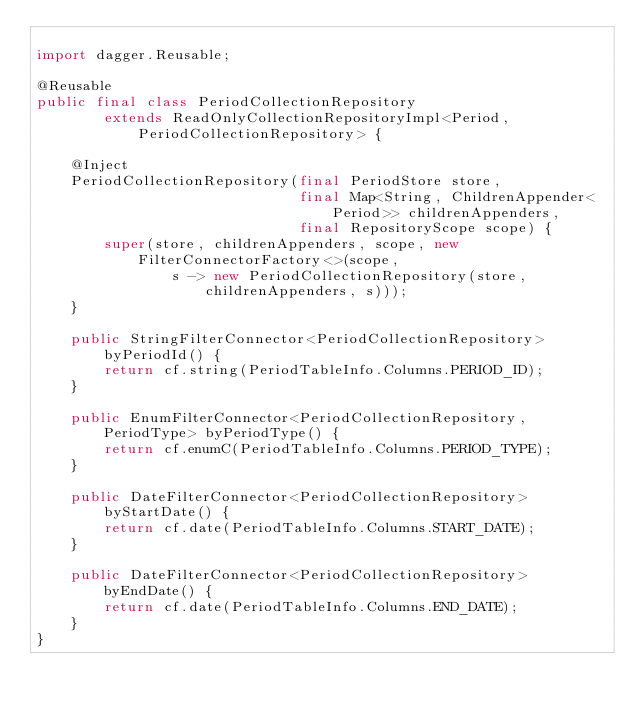Convert code to text. <code><loc_0><loc_0><loc_500><loc_500><_Java_>
import dagger.Reusable;

@Reusable
public final class PeriodCollectionRepository
        extends ReadOnlyCollectionRepositoryImpl<Period, PeriodCollectionRepository> {

    @Inject
    PeriodCollectionRepository(final PeriodStore store,
                               final Map<String, ChildrenAppender<Period>> childrenAppenders,
                               final RepositoryScope scope) {
        super(store, childrenAppenders, scope, new FilterConnectorFactory<>(scope,
                s -> new PeriodCollectionRepository(store, childrenAppenders, s)));
    }

    public StringFilterConnector<PeriodCollectionRepository> byPeriodId() {
        return cf.string(PeriodTableInfo.Columns.PERIOD_ID);
    }

    public EnumFilterConnector<PeriodCollectionRepository, PeriodType> byPeriodType() {
        return cf.enumC(PeriodTableInfo.Columns.PERIOD_TYPE);
    }

    public DateFilterConnector<PeriodCollectionRepository> byStartDate() {
        return cf.date(PeriodTableInfo.Columns.START_DATE);
    }

    public DateFilterConnector<PeriodCollectionRepository> byEndDate() {
        return cf.date(PeriodTableInfo.Columns.END_DATE);
    }
}</code> 